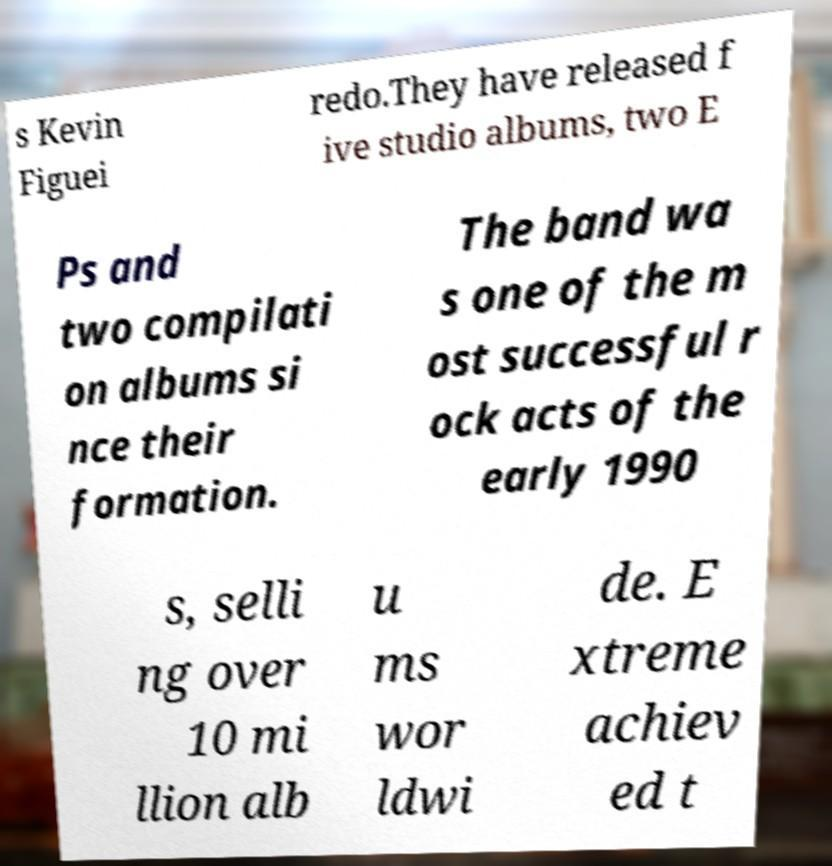There's text embedded in this image that I need extracted. Can you transcribe it verbatim? s Kevin Figuei redo.They have released f ive studio albums, two E Ps and two compilati on albums si nce their formation. The band wa s one of the m ost successful r ock acts of the early 1990 s, selli ng over 10 mi llion alb u ms wor ldwi de. E xtreme achiev ed t 